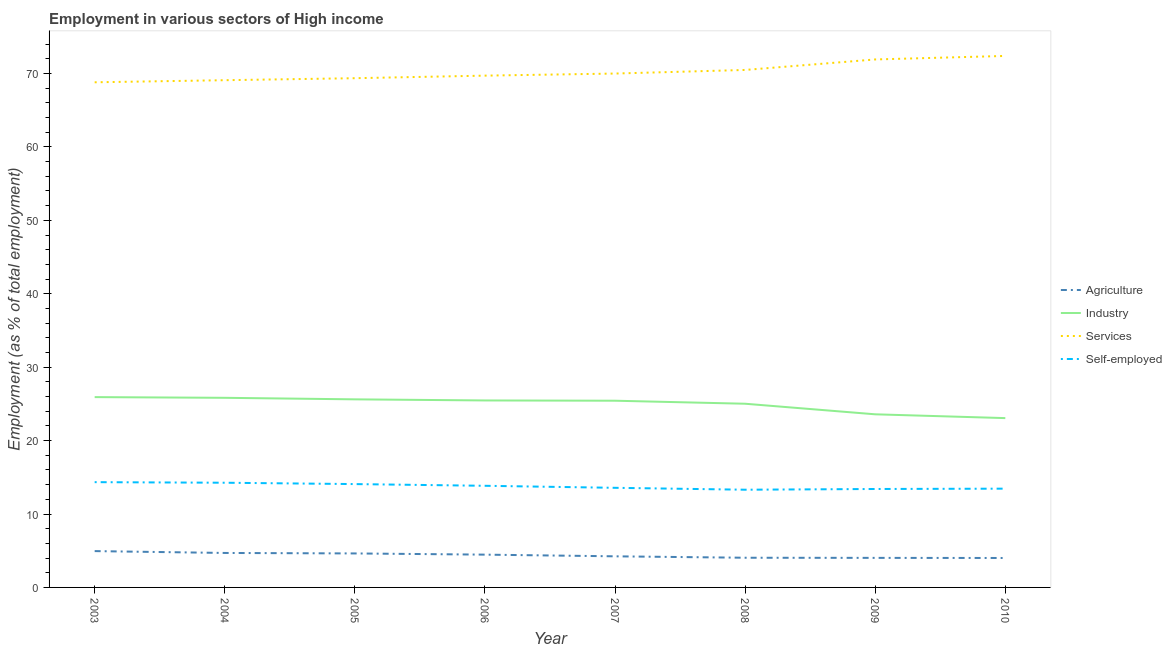How many different coloured lines are there?
Your response must be concise. 4. Does the line corresponding to percentage of self employed workers intersect with the line corresponding to percentage of workers in agriculture?
Make the answer very short. No. What is the percentage of workers in agriculture in 2008?
Ensure brevity in your answer.  4.04. Across all years, what is the maximum percentage of workers in agriculture?
Your response must be concise. 4.95. Across all years, what is the minimum percentage of workers in services?
Offer a very short reply. 68.81. In which year was the percentage of workers in industry maximum?
Your answer should be very brief. 2003. In which year was the percentage of self employed workers minimum?
Your response must be concise. 2008. What is the total percentage of workers in agriculture in the graph?
Keep it short and to the point. 35.06. What is the difference between the percentage of workers in industry in 2003 and that in 2008?
Offer a terse response. 0.9. What is the difference between the percentage of workers in agriculture in 2009 and the percentage of workers in industry in 2010?
Your answer should be compact. -19.04. What is the average percentage of self employed workers per year?
Give a very brief answer. 13.78. In the year 2003, what is the difference between the percentage of self employed workers and percentage of workers in services?
Your answer should be very brief. -54.47. What is the ratio of the percentage of self employed workers in 2003 to that in 2010?
Offer a terse response. 1.07. Is the percentage of workers in agriculture in 2003 less than that in 2009?
Offer a very short reply. No. What is the difference between the highest and the second highest percentage of self employed workers?
Offer a terse response. 0.08. What is the difference between the highest and the lowest percentage of workers in agriculture?
Your answer should be very brief. 0.94. In how many years, is the percentage of workers in industry greater than the average percentage of workers in industry taken over all years?
Provide a short and direct response. 6. Is the sum of the percentage of workers in agriculture in 2004 and 2008 greater than the maximum percentage of workers in industry across all years?
Your answer should be very brief. No. Does the percentage of workers in industry monotonically increase over the years?
Your response must be concise. No. Is the percentage of workers in services strictly greater than the percentage of workers in industry over the years?
Provide a succinct answer. Yes. What is the difference between two consecutive major ticks on the Y-axis?
Keep it short and to the point. 10. Are the values on the major ticks of Y-axis written in scientific E-notation?
Give a very brief answer. No. Does the graph contain any zero values?
Offer a very short reply. No. Does the graph contain grids?
Your answer should be very brief. No. Where does the legend appear in the graph?
Ensure brevity in your answer.  Center right. What is the title of the graph?
Provide a succinct answer. Employment in various sectors of High income. Does "Public resource use" appear as one of the legend labels in the graph?
Your answer should be compact. No. What is the label or title of the Y-axis?
Make the answer very short. Employment (as % of total employment). What is the Employment (as % of total employment) in Agriculture in 2003?
Your answer should be compact. 4.95. What is the Employment (as % of total employment) of Industry in 2003?
Provide a short and direct response. 25.92. What is the Employment (as % of total employment) of Services in 2003?
Your answer should be compact. 68.81. What is the Employment (as % of total employment) in Self-employed in 2003?
Provide a succinct answer. 14.34. What is the Employment (as % of total employment) in Agriculture in 2004?
Offer a terse response. 4.7. What is the Employment (as % of total employment) in Industry in 2004?
Give a very brief answer. 25.83. What is the Employment (as % of total employment) of Services in 2004?
Your response must be concise. 69.09. What is the Employment (as % of total employment) in Self-employed in 2004?
Offer a terse response. 14.26. What is the Employment (as % of total employment) of Agriculture in 2005?
Offer a very short reply. 4.63. What is the Employment (as % of total employment) in Industry in 2005?
Keep it short and to the point. 25.62. What is the Employment (as % of total employment) of Services in 2005?
Provide a short and direct response. 69.36. What is the Employment (as % of total employment) of Self-employed in 2005?
Give a very brief answer. 14.08. What is the Employment (as % of total employment) of Agriculture in 2006?
Give a very brief answer. 4.47. What is the Employment (as % of total employment) in Industry in 2006?
Provide a succinct answer. 25.47. What is the Employment (as % of total employment) of Services in 2006?
Ensure brevity in your answer.  69.71. What is the Employment (as % of total employment) in Self-employed in 2006?
Your response must be concise. 13.84. What is the Employment (as % of total employment) of Agriculture in 2007?
Ensure brevity in your answer.  4.24. What is the Employment (as % of total employment) of Industry in 2007?
Your answer should be very brief. 25.43. What is the Employment (as % of total employment) in Services in 2007?
Keep it short and to the point. 70. What is the Employment (as % of total employment) of Self-employed in 2007?
Make the answer very short. 13.57. What is the Employment (as % of total employment) of Agriculture in 2008?
Offer a terse response. 4.04. What is the Employment (as % of total employment) in Industry in 2008?
Ensure brevity in your answer.  25.02. What is the Employment (as % of total employment) in Services in 2008?
Your answer should be very brief. 70.49. What is the Employment (as % of total employment) of Self-employed in 2008?
Your answer should be compact. 13.31. What is the Employment (as % of total employment) of Agriculture in 2009?
Offer a very short reply. 4.03. What is the Employment (as % of total employment) of Industry in 2009?
Give a very brief answer. 23.58. What is the Employment (as % of total employment) in Services in 2009?
Your answer should be compact. 71.92. What is the Employment (as % of total employment) of Self-employed in 2009?
Ensure brevity in your answer.  13.41. What is the Employment (as % of total employment) in Agriculture in 2010?
Provide a succinct answer. 4.01. What is the Employment (as % of total employment) of Industry in 2010?
Offer a very short reply. 23.06. What is the Employment (as % of total employment) in Services in 2010?
Your answer should be very brief. 72.4. What is the Employment (as % of total employment) in Self-employed in 2010?
Ensure brevity in your answer.  13.45. Across all years, what is the maximum Employment (as % of total employment) in Agriculture?
Make the answer very short. 4.95. Across all years, what is the maximum Employment (as % of total employment) of Industry?
Your answer should be compact. 25.92. Across all years, what is the maximum Employment (as % of total employment) in Services?
Keep it short and to the point. 72.4. Across all years, what is the maximum Employment (as % of total employment) in Self-employed?
Ensure brevity in your answer.  14.34. Across all years, what is the minimum Employment (as % of total employment) in Agriculture?
Your response must be concise. 4.01. Across all years, what is the minimum Employment (as % of total employment) of Industry?
Make the answer very short. 23.06. Across all years, what is the minimum Employment (as % of total employment) in Services?
Your answer should be compact. 68.81. Across all years, what is the minimum Employment (as % of total employment) of Self-employed?
Provide a succinct answer. 13.31. What is the total Employment (as % of total employment) of Agriculture in the graph?
Keep it short and to the point. 35.06. What is the total Employment (as % of total employment) of Industry in the graph?
Your answer should be very brief. 199.94. What is the total Employment (as % of total employment) of Services in the graph?
Your response must be concise. 561.78. What is the total Employment (as % of total employment) of Self-employed in the graph?
Your answer should be very brief. 110.26. What is the difference between the Employment (as % of total employment) in Agriculture in 2003 and that in 2004?
Your answer should be compact. 0.25. What is the difference between the Employment (as % of total employment) in Industry in 2003 and that in 2004?
Offer a terse response. 0.09. What is the difference between the Employment (as % of total employment) in Services in 2003 and that in 2004?
Offer a very short reply. -0.28. What is the difference between the Employment (as % of total employment) in Self-employed in 2003 and that in 2004?
Offer a terse response. 0.08. What is the difference between the Employment (as % of total employment) in Agriculture in 2003 and that in 2005?
Your answer should be compact. 0.32. What is the difference between the Employment (as % of total employment) in Industry in 2003 and that in 2005?
Offer a very short reply. 0.3. What is the difference between the Employment (as % of total employment) in Services in 2003 and that in 2005?
Offer a terse response. -0.56. What is the difference between the Employment (as % of total employment) in Self-employed in 2003 and that in 2005?
Provide a short and direct response. 0.26. What is the difference between the Employment (as % of total employment) in Agriculture in 2003 and that in 2006?
Provide a succinct answer. 0.48. What is the difference between the Employment (as % of total employment) in Industry in 2003 and that in 2006?
Give a very brief answer. 0.45. What is the difference between the Employment (as % of total employment) in Services in 2003 and that in 2006?
Your response must be concise. -0.91. What is the difference between the Employment (as % of total employment) of Self-employed in 2003 and that in 2006?
Provide a short and direct response. 0.5. What is the difference between the Employment (as % of total employment) of Agriculture in 2003 and that in 2007?
Ensure brevity in your answer.  0.71. What is the difference between the Employment (as % of total employment) in Industry in 2003 and that in 2007?
Your response must be concise. 0.49. What is the difference between the Employment (as % of total employment) in Services in 2003 and that in 2007?
Keep it short and to the point. -1.19. What is the difference between the Employment (as % of total employment) in Self-employed in 2003 and that in 2007?
Provide a short and direct response. 0.77. What is the difference between the Employment (as % of total employment) in Agriculture in 2003 and that in 2008?
Make the answer very short. 0.9. What is the difference between the Employment (as % of total employment) of Industry in 2003 and that in 2008?
Offer a very short reply. 0.9. What is the difference between the Employment (as % of total employment) in Services in 2003 and that in 2008?
Keep it short and to the point. -1.68. What is the difference between the Employment (as % of total employment) in Self-employed in 2003 and that in 2008?
Provide a short and direct response. 1.03. What is the difference between the Employment (as % of total employment) in Agriculture in 2003 and that in 2009?
Your response must be concise. 0.92. What is the difference between the Employment (as % of total employment) in Industry in 2003 and that in 2009?
Provide a succinct answer. 2.34. What is the difference between the Employment (as % of total employment) of Services in 2003 and that in 2009?
Your response must be concise. -3.11. What is the difference between the Employment (as % of total employment) in Self-employed in 2003 and that in 2009?
Ensure brevity in your answer.  0.93. What is the difference between the Employment (as % of total employment) of Agriculture in 2003 and that in 2010?
Your answer should be compact. 0.94. What is the difference between the Employment (as % of total employment) in Industry in 2003 and that in 2010?
Offer a very short reply. 2.86. What is the difference between the Employment (as % of total employment) of Services in 2003 and that in 2010?
Provide a short and direct response. -3.59. What is the difference between the Employment (as % of total employment) in Self-employed in 2003 and that in 2010?
Offer a very short reply. 0.89. What is the difference between the Employment (as % of total employment) of Agriculture in 2004 and that in 2005?
Keep it short and to the point. 0.07. What is the difference between the Employment (as % of total employment) of Industry in 2004 and that in 2005?
Provide a succinct answer. 0.21. What is the difference between the Employment (as % of total employment) of Services in 2004 and that in 2005?
Offer a very short reply. -0.27. What is the difference between the Employment (as % of total employment) in Self-employed in 2004 and that in 2005?
Provide a succinct answer. 0.18. What is the difference between the Employment (as % of total employment) of Agriculture in 2004 and that in 2006?
Offer a very short reply. 0.23. What is the difference between the Employment (as % of total employment) in Industry in 2004 and that in 2006?
Keep it short and to the point. 0.36. What is the difference between the Employment (as % of total employment) of Services in 2004 and that in 2006?
Offer a very short reply. -0.62. What is the difference between the Employment (as % of total employment) of Self-employed in 2004 and that in 2006?
Your answer should be very brief. 0.42. What is the difference between the Employment (as % of total employment) of Agriculture in 2004 and that in 2007?
Ensure brevity in your answer.  0.46. What is the difference between the Employment (as % of total employment) of Industry in 2004 and that in 2007?
Provide a succinct answer. 0.4. What is the difference between the Employment (as % of total employment) in Services in 2004 and that in 2007?
Make the answer very short. -0.91. What is the difference between the Employment (as % of total employment) of Self-employed in 2004 and that in 2007?
Your answer should be very brief. 0.69. What is the difference between the Employment (as % of total employment) in Agriculture in 2004 and that in 2008?
Ensure brevity in your answer.  0.65. What is the difference between the Employment (as % of total employment) in Industry in 2004 and that in 2008?
Your answer should be compact. 0.81. What is the difference between the Employment (as % of total employment) of Services in 2004 and that in 2008?
Your response must be concise. -1.4. What is the difference between the Employment (as % of total employment) of Self-employed in 2004 and that in 2008?
Ensure brevity in your answer.  0.95. What is the difference between the Employment (as % of total employment) in Agriculture in 2004 and that in 2009?
Your response must be concise. 0.67. What is the difference between the Employment (as % of total employment) in Industry in 2004 and that in 2009?
Ensure brevity in your answer.  2.25. What is the difference between the Employment (as % of total employment) in Services in 2004 and that in 2009?
Keep it short and to the point. -2.83. What is the difference between the Employment (as % of total employment) in Self-employed in 2004 and that in 2009?
Offer a terse response. 0.85. What is the difference between the Employment (as % of total employment) in Agriculture in 2004 and that in 2010?
Your answer should be compact. 0.69. What is the difference between the Employment (as % of total employment) in Industry in 2004 and that in 2010?
Provide a succinct answer. 2.76. What is the difference between the Employment (as % of total employment) of Services in 2004 and that in 2010?
Your answer should be very brief. -3.31. What is the difference between the Employment (as % of total employment) of Self-employed in 2004 and that in 2010?
Your answer should be compact. 0.81. What is the difference between the Employment (as % of total employment) in Agriculture in 2005 and that in 2006?
Make the answer very short. 0.16. What is the difference between the Employment (as % of total employment) of Industry in 2005 and that in 2006?
Provide a succinct answer. 0.15. What is the difference between the Employment (as % of total employment) of Services in 2005 and that in 2006?
Your response must be concise. -0.35. What is the difference between the Employment (as % of total employment) of Self-employed in 2005 and that in 2006?
Your answer should be compact. 0.23. What is the difference between the Employment (as % of total employment) in Agriculture in 2005 and that in 2007?
Make the answer very short. 0.39. What is the difference between the Employment (as % of total employment) of Industry in 2005 and that in 2007?
Offer a terse response. 0.19. What is the difference between the Employment (as % of total employment) of Services in 2005 and that in 2007?
Your answer should be compact. -0.63. What is the difference between the Employment (as % of total employment) of Self-employed in 2005 and that in 2007?
Keep it short and to the point. 0.51. What is the difference between the Employment (as % of total employment) of Agriculture in 2005 and that in 2008?
Your response must be concise. 0.59. What is the difference between the Employment (as % of total employment) in Industry in 2005 and that in 2008?
Provide a short and direct response. 0.6. What is the difference between the Employment (as % of total employment) in Services in 2005 and that in 2008?
Keep it short and to the point. -1.12. What is the difference between the Employment (as % of total employment) in Self-employed in 2005 and that in 2008?
Make the answer very short. 0.77. What is the difference between the Employment (as % of total employment) of Agriculture in 2005 and that in 2009?
Make the answer very short. 0.6. What is the difference between the Employment (as % of total employment) in Industry in 2005 and that in 2009?
Give a very brief answer. 2.04. What is the difference between the Employment (as % of total employment) in Services in 2005 and that in 2009?
Offer a very short reply. -2.55. What is the difference between the Employment (as % of total employment) in Self-employed in 2005 and that in 2009?
Provide a succinct answer. 0.67. What is the difference between the Employment (as % of total employment) in Agriculture in 2005 and that in 2010?
Offer a terse response. 0.62. What is the difference between the Employment (as % of total employment) of Industry in 2005 and that in 2010?
Offer a terse response. 2.56. What is the difference between the Employment (as % of total employment) in Services in 2005 and that in 2010?
Make the answer very short. -3.03. What is the difference between the Employment (as % of total employment) in Self-employed in 2005 and that in 2010?
Provide a short and direct response. 0.62. What is the difference between the Employment (as % of total employment) in Agriculture in 2006 and that in 2007?
Ensure brevity in your answer.  0.23. What is the difference between the Employment (as % of total employment) of Industry in 2006 and that in 2007?
Provide a short and direct response. 0.04. What is the difference between the Employment (as % of total employment) in Services in 2006 and that in 2007?
Your answer should be compact. -0.28. What is the difference between the Employment (as % of total employment) in Self-employed in 2006 and that in 2007?
Offer a very short reply. 0.28. What is the difference between the Employment (as % of total employment) of Agriculture in 2006 and that in 2008?
Your answer should be compact. 0.42. What is the difference between the Employment (as % of total employment) of Industry in 2006 and that in 2008?
Provide a succinct answer. 0.45. What is the difference between the Employment (as % of total employment) of Services in 2006 and that in 2008?
Provide a succinct answer. -0.77. What is the difference between the Employment (as % of total employment) of Self-employed in 2006 and that in 2008?
Keep it short and to the point. 0.53. What is the difference between the Employment (as % of total employment) of Agriculture in 2006 and that in 2009?
Keep it short and to the point. 0.44. What is the difference between the Employment (as % of total employment) of Industry in 2006 and that in 2009?
Provide a succinct answer. 1.89. What is the difference between the Employment (as % of total employment) of Services in 2006 and that in 2009?
Give a very brief answer. -2.21. What is the difference between the Employment (as % of total employment) in Self-employed in 2006 and that in 2009?
Offer a very short reply. 0.44. What is the difference between the Employment (as % of total employment) of Agriculture in 2006 and that in 2010?
Provide a short and direct response. 0.46. What is the difference between the Employment (as % of total employment) in Industry in 2006 and that in 2010?
Your response must be concise. 2.4. What is the difference between the Employment (as % of total employment) of Services in 2006 and that in 2010?
Keep it short and to the point. -2.68. What is the difference between the Employment (as % of total employment) in Self-employed in 2006 and that in 2010?
Make the answer very short. 0.39. What is the difference between the Employment (as % of total employment) in Agriculture in 2007 and that in 2008?
Offer a very short reply. 0.19. What is the difference between the Employment (as % of total employment) of Industry in 2007 and that in 2008?
Provide a succinct answer. 0.41. What is the difference between the Employment (as % of total employment) in Services in 2007 and that in 2008?
Make the answer very short. -0.49. What is the difference between the Employment (as % of total employment) of Self-employed in 2007 and that in 2008?
Offer a terse response. 0.26. What is the difference between the Employment (as % of total employment) of Agriculture in 2007 and that in 2009?
Make the answer very short. 0.21. What is the difference between the Employment (as % of total employment) of Industry in 2007 and that in 2009?
Your response must be concise. 1.85. What is the difference between the Employment (as % of total employment) of Services in 2007 and that in 2009?
Offer a very short reply. -1.92. What is the difference between the Employment (as % of total employment) in Self-employed in 2007 and that in 2009?
Your response must be concise. 0.16. What is the difference between the Employment (as % of total employment) in Agriculture in 2007 and that in 2010?
Your response must be concise. 0.23. What is the difference between the Employment (as % of total employment) in Industry in 2007 and that in 2010?
Ensure brevity in your answer.  2.37. What is the difference between the Employment (as % of total employment) in Services in 2007 and that in 2010?
Offer a very short reply. -2.4. What is the difference between the Employment (as % of total employment) of Self-employed in 2007 and that in 2010?
Make the answer very short. 0.11. What is the difference between the Employment (as % of total employment) of Agriculture in 2008 and that in 2009?
Your answer should be compact. 0.02. What is the difference between the Employment (as % of total employment) in Industry in 2008 and that in 2009?
Your answer should be compact. 1.44. What is the difference between the Employment (as % of total employment) of Services in 2008 and that in 2009?
Give a very brief answer. -1.43. What is the difference between the Employment (as % of total employment) in Self-employed in 2008 and that in 2009?
Make the answer very short. -0.1. What is the difference between the Employment (as % of total employment) of Agriculture in 2008 and that in 2010?
Your answer should be compact. 0.03. What is the difference between the Employment (as % of total employment) of Industry in 2008 and that in 2010?
Your response must be concise. 1.96. What is the difference between the Employment (as % of total employment) of Services in 2008 and that in 2010?
Offer a very short reply. -1.91. What is the difference between the Employment (as % of total employment) of Self-employed in 2008 and that in 2010?
Your response must be concise. -0.14. What is the difference between the Employment (as % of total employment) in Agriculture in 2009 and that in 2010?
Make the answer very short. 0.02. What is the difference between the Employment (as % of total employment) of Industry in 2009 and that in 2010?
Offer a very short reply. 0.52. What is the difference between the Employment (as % of total employment) in Services in 2009 and that in 2010?
Provide a short and direct response. -0.48. What is the difference between the Employment (as % of total employment) of Self-employed in 2009 and that in 2010?
Give a very brief answer. -0.05. What is the difference between the Employment (as % of total employment) in Agriculture in 2003 and the Employment (as % of total employment) in Industry in 2004?
Provide a succinct answer. -20.88. What is the difference between the Employment (as % of total employment) of Agriculture in 2003 and the Employment (as % of total employment) of Services in 2004?
Provide a succinct answer. -64.14. What is the difference between the Employment (as % of total employment) in Agriculture in 2003 and the Employment (as % of total employment) in Self-employed in 2004?
Ensure brevity in your answer.  -9.31. What is the difference between the Employment (as % of total employment) of Industry in 2003 and the Employment (as % of total employment) of Services in 2004?
Your answer should be compact. -43.17. What is the difference between the Employment (as % of total employment) of Industry in 2003 and the Employment (as % of total employment) of Self-employed in 2004?
Your answer should be compact. 11.66. What is the difference between the Employment (as % of total employment) of Services in 2003 and the Employment (as % of total employment) of Self-employed in 2004?
Offer a very short reply. 54.55. What is the difference between the Employment (as % of total employment) of Agriculture in 2003 and the Employment (as % of total employment) of Industry in 2005?
Offer a very short reply. -20.67. What is the difference between the Employment (as % of total employment) in Agriculture in 2003 and the Employment (as % of total employment) in Services in 2005?
Your answer should be very brief. -64.42. What is the difference between the Employment (as % of total employment) in Agriculture in 2003 and the Employment (as % of total employment) in Self-employed in 2005?
Your answer should be very brief. -9.13. What is the difference between the Employment (as % of total employment) of Industry in 2003 and the Employment (as % of total employment) of Services in 2005?
Give a very brief answer. -43.44. What is the difference between the Employment (as % of total employment) of Industry in 2003 and the Employment (as % of total employment) of Self-employed in 2005?
Provide a short and direct response. 11.85. What is the difference between the Employment (as % of total employment) in Services in 2003 and the Employment (as % of total employment) in Self-employed in 2005?
Your answer should be compact. 54.73. What is the difference between the Employment (as % of total employment) of Agriculture in 2003 and the Employment (as % of total employment) of Industry in 2006?
Ensure brevity in your answer.  -20.52. What is the difference between the Employment (as % of total employment) in Agriculture in 2003 and the Employment (as % of total employment) in Services in 2006?
Ensure brevity in your answer.  -64.77. What is the difference between the Employment (as % of total employment) in Agriculture in 2003 and the Employment (as % of total employment) in Self-employed in 2006?
Ensure brevity in your answer.  -8.9. What is the difference between the Employment (as % of total employment) of Industry in 2003 and the Employment (as % of total employment) of Services in 2006?
Your answer should be very brief. -43.79. What is the difference between the Employment (as % of total employment) of Industry in 2003 and the Employment (as % of total employment) of Self-employed in 2006?
Your response must be concise. 12.08. What is the difference between the Employment (as % of total employment) in Services in 2003 and the Employment (as % of total employment) in Self-employed in 2006?
Ensure brevity in your answer.  54.96. What is the difference between the Employment (as % of total employment) in Agriculture in 2003 and the Employment (as % of total employment) in Industry in 2007?
Make the answer very short. -20.48. What is the difference between the Employment (as % of total employment) of Agriculture in 2003 and the Employment (as % of total employment) of Services in 2007?
Your response must be concise. -65.05. What is the difference between the Employment (as % of total employment) in Agriculture in 2003 and the Employment (as % of total employment) in Self-employed in 2007?
Keep it short and to the point. -8.62. What is the difference between the Employment (as % of total employment) of Industry in 2003 and the Employment (as % of total employment) of Services in 2007?
Provide a succinct answer. -44.08. What is the difference between the Employment (as % of total employment) in Industry in 2003 and the Employment (as % of total employment) in Self-employed in 2007?
Make the answer very short. 12.35. What is the difference between the Employment (as % of total employment) in Services in 2003 and the Employment (as % of total employment) in Self-employed in 2007?
Your answer should be compact. 55.24. What is the difference between the Employment (as % of total employment) of Agriculture in 2003 and the Employment (as % of total employment) of Industry in 2008?
Your answer should be compact. -20.07. What is the difference between the Employment (as % of total employment) of Agriculture in 2003 and the Employment (as % of total employment) of Services in 2008?
Keep it short and to the point. -65.54. What is the difference between the Employment (as % of total employment) in Agriculture in 2003 and the Employment (as % of total employment) in Self-employed in 2008?
Give a very brief answer. -8.36. What is the difference between the Employment (as % of total employment) of Industry in 2003 and the Employment (as % of total employment) of Services in 2008?
Provide a short and direct response. -44.56. What is the difference between the Employment (as % of total employment) of Industry in 2003 and the Employment (as % of total employment) of Self-employed in 2008?
Keep it short and to the point. 12.61. What is the difference between the Employment (as % of total employment) of Services in 2003 and the Employment (as % of total employment) of Self-employed in 2008?
Offer a very short reply. 55.5. What is the difference between the Employment (as % of total employment) of Agriculture in 2003 and the Employment (as % of total employment) of Industry in 2009?
Ensure brevity in your answer.  -18.63. What is the difference between the Employment (as % of total employment) of Agriculture in 2003 and the Employment (as % of total employment) of Services in 2009?
Provide a short and direct response. -66.97. What is the difference between the Employment (as % of total employment) in Agriculture in 2003 and the Employment (as % of total employment) in Self-employed in 2009?
Provide a succinct answer. -8.46. What is the difference between the Employment (as % of total employment) in Industry in 2003 and the Employment (as % of total employment) in Services in 2009?
Offer a terse response. -46. What is the difference between the Employment (as % of total employment) of Industry in 2003 and the Employment (as % of total employment) of Self-employed in 2009?
Your response must be concise. 12.51. What is the difference between the Employment (as % of total employment) of Services in 2003 and the Employment (as % of total employment) of Self-employed in 2009?
Ensure brevity in your answer.  55.4. What is the difference between the Employment (as % of total employment) of Agriculture in 2003 and the Employment (as % of total employment) of Industry in 2010?
Offer a very short reply. -18.12. What is the difference between the Employment (as % of total employment) of Agriculture in 2003 and the Employment (as % of total employment) of Services in 2010?
Make the answer very short. -67.45. What is the difference between the Employment (as % of total employment) of Agriculture in 2003 and the Employment (as % of total employment) of Self-employed in 2010?
Make the answer very short. -8.51. What is the difference between the Employment (as % of total employment) in Industry in 2003 and the Employment (as % of total employment) in Services in 2010?
Your answer should be very brief. -46.47. What is the difference between the Employment (as % of total employment) in Industry in 2003 and the Employment (as % of total employment) in Self-employed in 2010?
Offer a very short reply. 12.47. What is the difference between the Employment (as % of total employment) in Services in 2003 and the Employment (as % of total employment) in Self-employed in 2010?
Ensure brevity in your answer.  55.35. What is the difference between the Employment (as % of total employment) of Agriculture in 2004 and the Employment (as % of total employment) of Industry in 2005?
Ensure brevity in your answer.  -20.92. What is the difference between the Employment (as % of total employment) in Agriculture in 2004 and the Employment (as % of total employment) in Services in 2005?
Make the answer very short. -64.67. What is the difference between the Employment (as % of total employment) in Agriculture in 2004 and the Employment (as % of total employment) in Self-employed in 2005?
Offer a very short reply. -9.38. What is the difference between the Employment (as % of total employment) in Industry in 2004 and the Employment (as % of total employment) in Services in 2005?
Provide a short and direct response. -43.54. What is the difference between the Employment (as % of total employment) in Industry in 2004 and the Employment (as % of total employment) in Self-employed in 2005?
Keep it short and to the point. 11.75. What is the difference between the Employment (as % of total employment) in Services in 2004 and the Employment (as % of total employment) in Self-employed in 2005?
Provide a short and direct response. 55.02. What is the difference between the Employment (as % of total employment) in Agriculture in 2004 and the Employment (as % of total employment) in Industry in 2006?
Your answer should be compact. -20.77. What is the difference between the Employment (as % of total employment) of Agriculture in 2004 and the Employment (as % of total employment) of Services in 2006?
Ensure brevity in your answer.  -65.02. What is the difference between the Employment (as % of total employment) of Agriculture in 2004 and the Employment (as % of total employment) of Self-employed in 2006?
Provide a succinct answer. -9.15. What is the difference between the Employment (as % of total employment) in Industry in 2004 and the Employment (as % of total employment) in Services in 2006?
Offer a terse response. -43.89. What is the difference between the Employment (as % of total employment) in Industry in 2004 and the Employment (as % of total employment) in Self-employed in 2006?
Offer a terse response. 11.98. What is the difference between the Employment (as % of total employment) of Services in 2004 and the Employment (as % of total employment) of Self-employed in 2006?
Your response must be concise. 55.25. What is the difference between the Employment (as % of total employment) in Agriculture in 2004 and the Employment (as % of total employment) in Industry in 2007?
Offer a terse response. -20.74. What is the difference between the Employment (as % of total employment) of Agriculture in 2004 and the Employment (as % of total employment) of Services in 2007?
Ensure brevity in your answer.  -65.3. What is the difference between the Employment (as % of total employment) in Agriculture in 2004 and the Employment (as % of total employment) in Self-employed in 2007?
Ensure brevity in your answer.  -8.87. What is the difference between the Employment (as % of total employment) of Industry in 2004 and the Employment (as % of total employment) of Services in 2007?
Make the answer very short. -44.17. What is the difference between the Employment (as % of total employment) in Industry in 2004 and the Employment (as % of total employment) in Self-employed in 2007?
Keep it short and to the point. 12.26. What is the difference between the Employment (as % of total employment) in Services in 2004 and the Employment (as % of total employment) in Self-employed in 2007?
Make the answer very short. 55.52. What is the difference between the Employment (as % of total employment) in Agriculture in 2004 and the Employment (as % of total employment) in Industry in 2008?
Your response must be concise. -20.33. What is the difference between the Employment (as % of total employment) in Agriculture in 2004 and the Employment (as % of total employment) in Services in 2008?
Give a very brief answer. -65.79. What is the difference between the Employment (as % of total employment) of Agriculture in 2004 and the Employment (as % of total employment) of Self-employed in 2008?
Give a very brief answer. -8.61. What is the difference between the Employment (as % of total employment) of Industry in 2004 and the Employment (as % of total employment) of Services in 2008?
Your answer should be compact. -44.66. What is the difference between the Employment (as % of total employment) of Industry in 2004 and the Employment (as % of total employment) of Self-employed in 2008?
Offer a terse response. 12.52. What is the difference between the Employment (as % of total employment) in Services in 2004 and the Employment (as % of total employment) in Self-employed in 2008?
Your response must be concise. 55.78. What is the difference between the Employment (as % of total employment) in Agriculture in 2004 and the Employment (as % of total employment) in Industry in 2009?
Your answer should be very brief. -18.88. What is the difference between the Employment (as % of total employment) of Agriculture in 2004 and the Employment (as % of total employment) of Services in 2009?
Give a very brief answer. -67.22. What is the difference between the Employment (as % of total employment) of Agriculture in 2004 and the Employment (as % of total employment) of Self-employed in 2009?
Provide a succinct answer. -8.71. What is the difference between the Employment (as % of total employment) in Industry in 2004 and the Employment (as % of total employment) in Services in 2009?
Offer a terse response. -46.09. What is the difference between the Employment (as % of total employment) in Industry in 2004 and the Employment (as % of total employment) in Self-employed in 2009?
Offer a very short reply. 12.42. What is the difference between the Employment (as % of total employment) of Services in 2004 and the Employment (as % of total employment) of Self-employed in 2009?
Ensure brevity in your answer.  55.68. What is the difference between the Employment (as % of total employment) of Agriculture in 2004 and the Employment (as % of total employment) of Industry in 2010?
Keep it short and to the point. -18.37. What is the difference between the Employment (as % of total employment) in Agriculture in 2004 and the Employment (as % of total employment) in Services in 2010?
Provide a succinct answer. -67.7. What is the difference between the Employment (as % of total employment) of Agriculture in 2004 and the Employment (as % of total employment) of Self-employed in 2010?
Offer a terse response. -8.76. What is the difference between the Employment (as % of total employment) in Industry in 2004 and the Employment (as % of total employment) in Services in 2010?
Provide a succinct answer. -46.57. What is the difference between the Employment (as % of total employment) in Industry in 2004 and the Employment (as % of total employment) in Self-employed in 2010?
Your answer should be very brief. 12.37. What is the difference between the Employment (as % of total employment) of Services in 2004 and the Employment (as % of total employment) of Self-employed in 2010?
Keep it short and to the point. 55.64. What is the difference between the Employment (as % of total employment) of Agriculture in 2005 and the Employment (as % of total employment) of Industry in 2006?
Provide a short and direct response. -20.84. What is the difference between the Employment (as % of total employment) of Agriculture in 2005 and the Employment (as % of total employment) of Services in 2006?
Offer a very short reply. -65.08. What is the difference between the Employment (as % of total employment) in Agriculture in 2005 and the Employment (as % of total employment) in Self-employed in 2006?
Your response must be concise. -9.21. What is the difference between the Employment (as % of total employment) of Industry in 2005 and the Employment (as % of total employment) of Services in 2006?
Offer a very short reply. -44.09. What is the difference between the Employment (as % of total employment) of Industry in 2005 and the Employment (as % of total employment) of Self-employed in 2006?
Offer a terse response. 11.78. What is the difference between the Employment (as % of total employment) in Services in 2005 and the Employment (as % of total employment) in Self-employed in 2006?
Your response must be concise. 55.52. What is the difference between the Employment (as % of total employment) of Agriculture in 2005 and the Employment (as % of total employment) of Industry in 2007?
Provide a short and direct response. -20.8. What is the difference between the Employment (as % of total employment) of Agriculture in 2005 and the Employment (as % of total employment) of Services in 2007?
Make the answer very short. -65.37. What is the difference between the Employment (as % of total employment) of Agriculture in 2005 and the Employment (as % of total employment) of Self-employed in 2007?
Make the answer very short. -8.94. What is the difference between the Employment (as % of total employment) of Industry in 2005 and the Employment (as % of total employment) of Services in 2007?
Your answer should be very brief. -44.38. What is the difference between the Employment (as % of total employment) of Industry in 2005 and the Employment (as % of total employment) of Self-employed in 2007?
Provide a short and direct response. 12.05. What is the difference between the Employment (as % of total employment) of Services in 2005 and the Employment (as % of total employment) of Self-employed in 2007?
Your answer should be very brief. 55.8. What is the difference between the Employment (as % of total employment) in Agriculture in 2005 and the Employment (as % of total employment) in Industry in 2008?
Your answer should be compact. -20.39. What is the difference between the Employment (as % of total employment) in Agriculture in 2005 and the Employment (as % of total employment) in Services in 2008?
Your answer should be very brief. -65.86. What is the difference between the Employment (as % of total employment) of Agriculture in 2005 and the Employment (as % of total employment) of Self-employed in 2008?
Give a very brief answer. -8.68. What is the difference between the Employment (as % of total employment) in Industry in 2005 and the Employment (as % of total employment) in Services in 2008?
Offer a very short reply. -44.87. What is the difference between the Employment (as % of total employment) of Industry in 2005 and the Employment (as % of total employment) of Self-employed in 2008?
Your answer should be compact. 12.31. What is the difference between the Employment (as % of total employment) of Services in 2005 and the Employment (as % of total employment) of Self-employed in 2008?
Provide a short and direct response. 56.05. What is the difference between the Employment (as % of total employment) in Agriculture in 2005 and the Employment (as % of total employment) in Industry in 2009?
Provide a short and direct response. -18.95. What is the difference between the Employment (as % of total employment) in Agriculture in 2005 and the Employment (as % of total employment) in Services in 2009?
Ensure brevity in your answer.  -67.29. What is the difference between the Employment (as % of total employment) in Agriculture in 2005 and the Employment (as % of total employment) in Self-employed in 2009?
Ensure brevity in your answer.  -8.78. What is the difference between the Employment (as % of total employment) in Industry in 2005 and the Employment (as % of total employment) in Services in 2009?
Offer a terse response. -46.3. What is the difference between the Employment (as % of total employment) in Industry in 2005 and the Employment (as % of total employment) in Self-employed in 2009?
Your response must be concise. 12.21. What is the difference between the Employment (as % of total employment) in Services in 2005 and the Employment (as % of total employment) in Self-employed in 2009?
Give a very brief answer. 55.96. What is the difference between the Employment (as % of total employment) of Agriculture in 2005 and the Employment (as % of total employment) of Industry in 2010?
Your answer should be compact. -18.43. What is the difference between the Employment (as % of total employment) of Agriculture in 2005 and the Employment (as % of total employment) of Services in 2010?
Your response must be concise. -67.77. What is the difference between the Employment (as % of total employment) in Agriculture in 2005 and the Employment (as % of total employment) in Self-employed in 2010?
Give a very brief answer. -8.82. What is the difference between the Employment (as % of total employment) in Industry in 2005 and the Employment (as % of total employment) in Services in 2010?
Offer a terse response. -46.78. What is the difference between the Employment (as % of total employment) in Industry in 2005 and the Employment (as % of total employment) in Self-employed in 2010?
Provide a succinct answer. 12.17. What is the difference between the Employment (as % of total employment) in Services in 2005 and the Employment (as % of total employment) in Self-employed in 2010?
Offer a very short reply. 55.91. What is the difference between the Employment (as % of total employment) in Agriculture in 2006 and the Employment (as % of total employment) in Industry in 2007?
Your response must be concise. -20.97. What is the difference between the Employment (as % of total employment) of Agriculture in 2006 and the Employment (as % of total employment) of Services in 2007?
Make the answer very short. -65.53. What is the difference between the Employment (as % of total employment) in Agriculture in 2006 and the Employment (as % of total employment) in Self-employed in 2007?
Offer a very short reply. -9.1. What is the difference between the Employment (as % of total employment) in Industry in 2006 and the Employment (as % of total employment) in Services in 2007?
Offer a very short reply. -44.53. What is the difference between the Employment (as % of total employment) of Industry in 2006 and the Employment (as % of total employment) of Self-employed in 2007?
Offer a very short reply. 11.9. What is the difference between the Employment (as % of total employment) of Services in 2006 and the Employment (as % of total employment) of Self-employed in 2007?
Your response must be concise. 56.15. What is the difference between the Employment (as % of total employment) of Agriculture in 2006 and the Employment (as % of total employment) of Industry in 2008?
Your response must be concise. -20.56. What is the difference between the Employment (as % of total employment) in Agriculture in 2006 and the Employment (as % of total employment) in Services in 2008?
Make the answer very short. -66.02. What is the difference between the Employment (as % of total employment) of Agriculture in 2006 and the Employment (as % of total employment) of Self-employed in 2008?
Provide a short and direct response. -8.84. What is the difference between the Employment (as % of total employment) of Industry in 2006 and the Employment (as % of total employment) of Services in 2008?
Your answer should be very brief. -45.02. What is the difference between the Employment (as % of total employment) of Industry in 2006 and the Employment (as % of total employment) of Self-employed in 2008?
Your answer should be compact. 12.16. What is the difference between the Employment (as % of total employment) in Services in 2006 and the Employment (as % of total employment) in Self-employed in 2008?
Offer a very short reply. 56.4. What is the difference between the Employment (as % of total employment) in Agriculture in 2006 and the Employment (as % of total employment) in Industry in 2009?
Your response must be concise. -19.11. What is the difference between the Employment (as % of total employment) in Agriculture in 2006 and the Employment (as % of total employment) in Services in 2009?
Offer a terse response. -67.45. What is the difference between the Employment (as % of total employment) in Agriculture in 2006 and the Employment (as % of total employment) in Self-employed in 2009?
Provide a short and direct response. -8.94. What is the difference between the Employment (as % of total employment) of Industry in 2006 and the Employment (as % of total employment) of Services in 2009?
Your answer should be very brief. -46.45. What is the difference between the Employment (as % of total employment) of Industry in 2006 and the Employment (as % of total employment) of Self-employed in 2009?
Your response must be concise. 12.06. What is the difference between the Employment (as % of total employment) in Services in 2006 and the Employment (as % of total employment) in Self-employed in 2009?
Your answer should be very brief. 56.31. What is the difference between the Employment (as % of total employment) of Agriculture in 2006 and the Employment (as % of total employment) of Industry in 2010?
Provide a succinct answer. -18.6. What is the difference between the Employment (as % of total employment) of Agriculture in 2006 and the Employment (as % of total employment) of Services in 2010?
Ensure brevity in your answer.  -67.93. What is the difference between the Employment (as % of total employment) of Agriculture in 2006 and the Employment (as % of total employment) of Self-employed in 2010?
Make the answer very short. -8.99. What is the difference between the Employment (as % of total employment) of Industry in 2006 and the Employment (as % of total employment) of Services in 2010?
Offer a very short reply. -46.93. What is the difference between the Employment (as % of total employment) of Industry in 2006 and the Employment (as % of total employment) of Self-employed in 2010?
Make the answer very short. 12.01. What is the difference between the Employment (as % of total employment) in Services in 2006 and the Employment (as % of total employment) in Self-employed in 2010?
Offer a very short reply. 56.26. What is the difference between the Employment (as % of total employment) of Agriculture in 2007 and the Employment (as % of total employment) of Industry in 2008?
Give a very brief answer. -20.78. What is the difference between the Employment (as % of total employment) in Agriculture in 2007 and the Employment (as % of total employment) in Services in 2008?
Your answer should be compact. -66.25. What is the difference between the Employment (as % of total employment) of Agriculture in 2007 and the Employment (as % of total employment) of Self-employed in 2008?
Give a very brief answer. -9.07. What is the difference between the Employment (as % of total employment) in Industry in 2007 and the Employment (as % of total employment) in Services in 2008?
Keep it short and to the point. -45.06. What is the difference between the Employment (as % of total employment) of Industry in 2007 and the Employment (as % of total employment) of Self-employed in 2008?
Give a very brief answer. 12.12. What is the difference between the Employment (as % of total employment) of Services in 2007 and the Employment (as % of total employment) of Self-employed in 2008?
Ensure brevity in your answer.  56.69. What is the difference between the Employment (as % of total employment) of Agriculture in 2007 and the Employment (as % of total employment) of Industry in 2009?
Ensure brevity in your answer.  -19.34. What is the difference between the Employment (as % of total employment) of Agriculture in 2007 and the Employment (as % of total employment) of Services in 2009?
Make the answer very short. -67.68. What is the difference between the Employment (as % of total employment) of Agriculture in 2007 and the Employment (as % of total employment) of Self-employed in 2009?
Offer a very short reply. -9.17. What is the difference between the Employment (as % of total employment) in Industry in 2007 and the Employment (as % of total employment) in Services in 2009?
Provide a short and direct response. -46.49. What is the difference between the Employment (as % of total employment) in Industry in 2007 and the Employment (as % of total employment) in Self-employed in 2009?
Your response must be concise. 12.02. What is the difference between the Employment (as % of total employment) in Services in 2007 and the Employment (as % of total employment) in Self-employed in 2009?
Ensure brevity in your answer.  56.59. What is the difference between the Employment (as % of total employment) in Agriculture in 2007 and the Employment (as % of total employment) in Industry in 2010?
Keep it short and to the point. -18.83. What is the difference between the Employment (as % of total employment) of Agriculture in 2007 and the Employment (as % of total employment) of Services in 2010?
Give a very brief answer. -68.16. What is the difference between the Employment (as % of total employment) in Agriculture in 2007 and the Employment (as % of total employment) in Self-employed in 2010?
Offer a very short reply. -9.22. What is the difference between the Employment (as % of total employment) of Industry in 2007 and the Employment (as % of total employment) of Services in 2010?
Offer a very short reply. -46.97. What is the difference between the Employment (as % of total employment) in Industry in 2007 and the Employment (as % of total employment) in Self-employed in 2010?
Provide a succinct answer. 11.98. What is the difference between the Employment (as % of total employment) in Services in 2007 and the Employment (as % of total employment) in Self-employed in 2010?
Provide a succinct answer. 56.54. What is the difference between the Employment (as % of total employment) of Agriculture in 2008 and the Employment (as % of total employment) of Industry in 2009?
Give a very brief answer. -19.54. What is the difference between the Employment (as % of total employment) in Agriculture in 2008 and the Employment (as % of total employment) in Services in 2009?
Your answer should be compact. -67.88. What is the difference between the Employment (as % of total employment) in Agriculture in 2008 and the Employment (as % of total employment) in Self-employed in 2009?
Your answer should be very brief. -9.36. What is the difference between the Employment (as % of total employment) of Industry in 2008 and the Employment (as % of total employment) of Services in 2009?
Give a very brief answer. -46.9. What is the difference between the Employment (as % of total employment) of Industry in 2008 and the Employment (as % of total employment) of Self-employed in 2009?
Give a very brief answer. 11.61. What is the difference between the Employment (as % of total employment) in Services in 2008 and the Employment (as % of total employment) in Self-employed in 2009?
Keep it short and to the point. 57.08. What is the difference between the Employment (as % of total employment) of Agriculture in 2008 and the Employment (as % of total employment) of Industry in 2010?
Offer a terse response. -19.02. What is the difference between the Employment (as % of total employment) in Agriculture in 2008 and the Employment (as % of total employment) in Services in 2010?
Offer a terse response. -68.35. What is the difference between the Employment (as % of total employment) in Agriculture in 2008 and the Employment (as % of total employment) in Self-employed in 2010?
Make the answer very short. -9.41. What is the difference between the Employment (as % of total employment) of Industry in 2008 and the Employment (as % of total employment) of Services in 2010?
Provide a short and direct response. -47.38. What is the difference between the Employment (as % of total employment) in Industry in 2008 and the Employment (as % of total employment) in Self-employed in 2010?
Offer a very short reply. 11.57. What is the difference between the Employment (as % of total employment) in Services in 2008 and the Employment (as % of total employment) in Self-employed in 2010?
Give a very brief answer. 57.03. What is the difference between the Employment (as % of total employment) in Agriculture in 2009 and the Employment (as % of total employment) in Industry in 2010?
Keep it short and to the point. -19.04. What is the difference between the Employment (as % of total employment) in Agriculture in 2009 and the Employment (as % of total employment) in Services in 2010?
Your answer should be compact. -68.37. What is the difference between the Employment (as % of total employment) in Agriculture in 2009 and the Employment (as % of total employment) in Self-employed in 2010?
Your answer should be compact. -9.43. What is the difference between the Employment (as % of total employment) of Industry in 2009 and the Employment (as % of total employment) of Services in 2010?
Keep it short and to the point. -48.82. What is the difference between the Employment (as % of total employment) in Industry in 2009 and the Employment (as % of total employment) in Self-employed in 2010?
Your response must be concise. 10.13. What is the difference between the Employment (as % of total employment) in Services in 2009 and the Employment (as % of total employment) in Self-employed in 2010?
Give a very brief answer. 58.46. What is the average Employment (as % of total employment) in Agriculture per year?
Your response must be concise. 4.38. What is the average Employment (as % of total employment) of Industry per year?
Your answer should be compact. 24.99. What is the average Employment (as % of total employment) in Services per year?
Make the answer very short. 70.22. What is the average Employment (as % of total employment) in Self-employed per year?
Offer a terse response. 13.78. In the year 2003, what is the difference between the Employment (as % of total employment) of Agriculture and Employment (as % of total employment) of Industry?
Ensure brevity in your answer.  -20.98. In the year 2003, what is the difference between the Employment (as % of total employment) in Agriculture and Employment (as % of total employment) in Services?
Ensure brevity in your answer.  -63.86. In the year 2003, what is the difference between the Employment (as % of total employment) in Agriculture and Employment (as % of total employment) in Self-employed?
Keep it short and to the point. -9.39. In the year 2003, what is the difference between the Employment (as % of total employment) of Industry and Employment (as % of total employment) of Services?
Provide a short and direct response. -42.88. In the year 2003, what is the difference between the Employment (as % of total employment) of Industry and Employment (as % of total employment) of Self-employed?
Offer a terse response. 11.58. In the year 2003, what is the difference between the Employment (as % of total employment) of Services and Employment (as % of total employment) of Self-employed?
Make the answer very short. 54.47. In the year 2004, what is the difference between the Employment (as % of total employment) of Agriculture and Employment (as % of total employment) of Industry?
Ensure brevity in your answer.  -21.13. In the year 2004, what is the difference between the Employment (as % of total employment) in Agriculture and Employment (as % of total employment) in Services?
Your answer should be very brief. -64.4. In the year 2004, what is the difference between the Employment (as % of total employment) in Agriculture and Employment (as % of total employment) in Self-employed?
Offer a terse response. -9.57. In the year 2004, what is the difference between the Employment (as % of total employment) in Industry and Employment (as % of total employment) in Services?
Offer a very short reply. -43.26. In the year 2004, what is the difference between the Employment (as % of total employment) in Industry and Employment (as % of total employment) in Self-employed?
Ensure brevity in your answer.  11.57. In the year 2004, what is the difference between the Employment (as % of total employment) of Services and Employment (as % of total employment) of Self-employed?
Make the answer very short. 54.83. In the year 2005, what is the difference between the Employment (as % of total employment) in Agriculture and Employment (as % of total employment) in Industry?
Make the answer very short. -20.99. In the year 2005, what is the difference between the Employment (as % of total employment) of Agriculture and Employment (as % of total employment) of Services?
Offer a terse response. -64.73. In the year 2005, what is the difference between the Employment (as % of total employment) of Agriculture and Employment (as % of total employment) of Self-employed?
Provide a succinct answer. -9.45. In the year 2005, what is the difference between the Employment (as % of total employment) in Industry and Employment (as % of total employment) in Services?
Give a very brief answer. -43.74. In the year 2005, what is the difference between the Employment (as % of total employment) of Industry and Employment (as % of total employment) of Self-employed?
Your answer should be compact. 11.54. In the year 2005, what is the difference between the Employment (as % of total employment) of Services and Employment (as % of total employment) of Self-employed?
Your response must be concise. 55.29. In the year 2006, what is the difference between the Employment (as % of total employment) in Agriculture and Employment (as % of total employment) in Industry?
Provide a short and direct response. -21. In the year 2006, what is the difference between the Employment (as % of total employment) in Agriculture and Employment (as % of total employment) in Services?
Keep it short and to the point. -65.25. In the year 2006, what is the difference between the Employment (as % of total employment) of Agriculture and Employment (as % of total employment) of Self-employed?
Keep it short and to the point. -9.38. In the year 2006, what is the difference between the Employment (as % of total employment) of Industry and Employment (as % of total employment) of Services?
Offer a terse response. -44.24. In the year 2006, what is the difference between the Employment (as % of total employment) of Industry and Employment (as % of total employment) of Self-employed?
Offer a very short reply. 11.62. In the year 2006, what is the difference between the Employment (as % of total employment) of Services and Employment (as % of total employment) of Self-employed?
Offer a very short reply. 55.87. In the year 2007, what is the difference between the Employment (as % of total employment) in Agriculture and Employment (as % of total employment) in Industry?
Offer a very short reply. -21.19. In the year 2007, what is the difference between the Employment (as % of total employment) of Agriculture and Employment (as % of total employment) of Services?
Provide a succinct answer. -65.76. In the year 2007, what is the difference between the Employment (as % of total employment) in Agriculture and Employment (as % of total employment) in Self-employed?
Keep it short and to the point. -9.33. In the year 2007, what is the difference between the Employment (as % of total employment) in Industry and Employment (as % of total employment) in Services?
Offer a terse response. -44.57. In the year 2007, what is the difference between the Employment (as % of total employment) of Industry and Employment (as % of total employment) of Self-employed?
Make the answer very short. 11.86. In the year 2007, what is the difference between the Employment (as % of total employment) of Services and Employment (as % of total employment) of Self-employed?
Your answer should be compact. 56.43. In the year 2008, what is the difference between the Employment (as % of total employment) of Agriculture and Employment (as % of total employment) of Industry?
Keep it short and to the point. -20.98. In the year 2008, what is the difference between the Employment (as % of total employment) in Agriculture and Employment (as % of total employment) in Services?
Offer a very short reply. -66.44. In the year 2008, what is the difference between the Employment (as % of total employment) in Agriculture and Employment (as % of total employment) in Self-employed?
Your response must be concise. -9.27. In the year 2008, what is the difference between the Employment (as % of total employment) of Industry and Employment (as % of total employment) of Services?
Provide a succinct answer. -45.47. In the year 2008, what is the difference between the Employment (as % of total employment) of Industry and Employment (as % of total employment) of Self-employed?
Make the answer very short. 11.71. In the year 2008, what is the difference between the Employment (as % of total employment) in Services and Employment (as % of total employment) in Self-employed?
Offer a terse response. 57.18. In the year 2009, what is the difference between the Employment (as % of total employment) in Agriculture and Employment (as % of total employment) in Industry?
Provide a short and direct response. -19.55. In the year 2009, what is the difference between the Employment (as % of total employment) in Agriculture and Employment (as % of total employment) in Services?
Your response must be concise. -67.89. In the year 2009, what is the difference between the Employment (as % of total employment) in Agriculture and Employment (as % of total employment) in Self-employed?
Offer a very short reply. -9.38. In the year 2009, what is the difference between the Employment (as % of total employment) in Industry and Employment (as % of total employment) in Services?
Give a very brief answer. -48.34. In the year 2009, what is the difference between the Employment (as % of total employment) of Industry and Employment (as % of total employment) of Self-employed?
Offer a very short reply. 10.17. In the year 2009, what is the difference between the Employment (as % of total employment) in Services and Employment (as % of total employment) in Self-employed?
Provide a short and direct response. 58.51. In the year 2010, what is the difference between the Employment (as % of total employment) of Agriculture and Employment (as % of total employment) of Industry?
Your response must be concise. -19.05. In the year 2010, what is the difference between the Employment (as % of total employment) of Agriculture and Employment (as % of total employment) of Services?
Offer a terse response. -68.39. In the year 2010, what is the difference between the Employment (as % of total employment) in Agriculture and Employment (as % of total employment) in Self-employed?
Provide a succinct answer. -9.44. In the year 2010, what is the difference between the Employment (as % of total employment) of Industry and Employment (as % of total employment) of Services?
Make the answer very short. -49.33. In the year 2010, what is the difference between the Employment (as % of total employment) of Industry and Employment (as % of total employment) of Self-employed?
Keep it short and to the point. 9.61. In the year 2010, what is the difference between the Employment (as % of total employment) of Services and Employment (as % of total employment) of Self-employed?
Offer a very short reply. 58.94. What is the ratio of the Employment (as % of total employment) in Agriculture in 2003 to that in 2004?
Make the answer very short. 1.05. What is the ratio of the Employment (as % of total employment) of Self-employed in 2003 to that in 2004?
Your answer should be compact. 1.01. What is the ratio of the Employment (as % of total employment) of Agriculture in 2003 to that in 2005?
Make the answer very short. 1.07. What is the ratio of the Employment (as % of total employment) in Industry in 2003 to that in 2005?
Ensure brevity in your answer.  1.01. What is the ratio of the Employment (as % of total employment) of Services in 2003 to that in 2005?
Offer a terse response. 0.99. What is the ratio of the Employment (as % of total employment) in Self-employed in 2003 to that in 2005?
Offer a very short reply. 1.02. What is the ratio of the Employment (as % of total employment) in Agriculture in 2003 to that in 2006?
Give a very brief answer. 1.11. What is the ratio of the Employment (as % of total employment) of Industry in 2003 to that in 2006?
Offer a terse response. 1.02. What is the ratio of the Employment (as % of total employment) in Self-employed in 2003 to that in 2006?
Keep it short and to the point. 1.04. What is the ratio of the Employment (as % of total employment) in Agriculture in 2003 to that in 2007?
Offer a very short reply. 1.17. What is the ratio of the Employment (as % of total employment) of Industry in 2003 to that in 2007?
Make the answer very short. 1.02. What is the ratio of the Employment (as % of total employment) of Services in 2003 to that in 2007?
Offer a terse response. 0.98. What is the ratio of the Employment (as % of total employment) of Self-employed in 2003 to that in 2007?
Your answer should be very brief. 1.06. What is the ratio of the Employment (as % of total employment) of Agriculture in 2003 to that in 2008?
Provide a short and direct response. 1.22. What is the ratio of the Employment (as % of total employment) in Industry in 2003 to that in 2008?
Make the answer very short. 1.04. What is the ratio of the Employment (as % of total employment) in Services in 2003 to that in 2008?
Provide a short and direct response. 0.98. What is the ratio of the Employment (as % of total employment) in Self-employed in 2003 to that in 2008?
Make the answer very short. 1.08. What is the ratio of the Employment (as % of total employment) in Agriculture in 2003 to that in 2009?
Your answer should be very brief. 1.23. What is the ratio of the Employment (as % of total employment) of Industry in 2003 to that in 2009?
Provide a short and direct response. 1.1. What is the ratio of the Employment (as % of total employment) in Services in 2003 to that in 2009?
Offer a terse response. 0.96. What is the ratio of the Employment (as % of total employment) of Self-employed in 2003 to that in 2009?
Provide a succinct answer. 1.07. What is the ratio of the Employment (as % of total employment) in Agriculture in 2003 to that in 2010?
Your response must be concise. 1.23. What is the ratio of the Employment (as % of total employment) in Industry in 2003 to that in 2010?
Offer a terse response. 1.12. What is the ratio of the Employment (as % of total employment) of Services in 2003 to that in 2010?
Ensure brevity in your answer.  0.95. What is the ratio of the Employment (as % of total employment) in Self-employed in 2003 to that in 2010?
Provide a short and direct response. 1.07. What is the ratio of the Employment (as % of total employment) in Agriculture in 2004 to that in 2005?
Keep it short and to the point. 1.01. What is the ratio of the Employment (as % of total employment) in Industry in 2004 to that in 2005?
Your response must be concise. 1.01. What is the ratio of the Employment (as % of total employment) in Services in 2004 to that in 2005?
Your answer should be very brief. 1. What is the ratio of the Employment (as % of total employment) in Self-employed in 2004 to that in 2005?
Offer a very short reply. 1.01. What is the ratio of the Employment (as % of total employment) in Agriculture in 2004 to that in 2006?
Your answer should be very brief. 1.05. What is the ratio of the Employment (as % of total employment) of Industry in 2004 to that in 2006?
Provide a succinct answer. 1.01. What is the ratio of the Employment (as % of total employment) of Self-employed in 2004 to that in 2006?
Provide a succinct answer. 1.03. What is the ratio of the Employment (as % of total employment) in Agriculture in 2004 to that in 2007?
Make the answer very short. 1.11. What is the ratio of the Employment (as % of total employment) of Industry in 2004 to that in 2007?
Provide a short and direct response. 1.02. What is the ratio of the Employment (as % of total employment) of Services in 2004 to that in 2007?
Offer a very short reply. 0.99. What is the ratio of the Employment (as % of total employment) in Self-employed in 2004 to that in 2007?
Make the answer very short. 1.05. What is the ratio of the Employment (as % of total employment) of Agriculture in 2004 to that in 2008?
Provide a succinct answer. 1.16. What is the ratio of the Employment (as % of total employment) in Industry in 2004 to that in 2008?
Offer a terse response. 1.03. What is the ratio of the Employment (as % of total employment) in Services in 2004 to that in 2008?
Offer a terse response. 0.98. What is the ratio of the Employment (as % of total employment) in Self-employed in 2004 to that in 2008?
Make the answer very short. 1.07. What is the ratio of the Employment (as % of total employment) in Agriculture in 2004 to that in 2009?
Your answer should be very brief. 1.17. What is the ratio of the Employment (as % of total employment) in Industry in 2004 to that in 2009?
Offer a terse response. 1.1. What is the ratio of the Employment (as % of total employment) in Services in 2004 to that in 2009?
Your answer should be very brief. 0.96. What is the ratio of the Employment (as % of total employment) in Self-employed in 2004 to that in 2009?
Provide a short and direct response. 1.06. What is the ratio of the Employment (as % of total employment) of Agriculture in 2004 to that in 2010?
Provide a succinct answer. 1.17. What is the ratio of the Employment (as % of total employment) in Industry in 2004 to that in 2010?
Provide a succinct answer. 1.12. What is the ratio of the Employment (as % of total employment) of Services in 2004 to that in 2010?
Make the answer very short. 0.95. What is the ratio of the Employment (as % of total employment) in Self-employed in 2004 to that in 2010?
Give a very brief answer. 1.06. What is the ratio of the Employment (as % of total employment) of Agriculture in 2005 to that in 2006?
Provide a short and direct response. 1.04. What is the ratio of the Employment (as % of total employment) of Industry in 2005 to that in 2006?
Offer a terse response. 1.01. What is the ratio of the Employment (as % of total employment) of Self-employed in 2005 to that in 2006?
Your answer should be very brief. 1.02. What is the ratio of the Employment (as % of total employment) of Agriculture in 2005 to that in 2007?
Give a very brief answer. 1.09. What is the ratio of the Employment (as % of total employment) in Industry in 2005 to that in 2007?
Make the answer very short. 1.01. What is the ratio of the Employment (as % of total employment) in Services in 2005 to that in 2007?
Your answer should be compact. 0.99. What is the ratio of the Employment (as % of total employment) in Self-employed in 2005 to that in 2007?
Keep it short and to the point. 1.04. What is the ratio of the Employment (as % of total employment) of Agriculture in 2005 to that in 2008?
Make the answer very short. 1.15. What is the ratio of the Employment (as % of total employment) of Industry in 2005 to that in 2008?
Offer a terse response. 1.02. What is the ratio of the Employment (as % of total employment) of Services in 2005 to that in 2008?
Provide a succinct answer. 0.98. What is the ratio of the Employment (as % of total employment) in Self-employed in 2005 to that in 2008?
Keep it short and to the point. 1.06. What is the ratio of the Employment (as % of total employment) in Agriculture in 2005 to that in 2009?
Offer a terse response. 1.15. What is the ratio of the Employment (as % of total employment) of Industry in 2005 to that in 2009?
Provide a succinct answer. 1.09. What is the ratio of the Employment (as % of total employment) in Services in 2005 to that in 2009?
Your response must be concise. 0.96. What is the ratio of the Employment (as % of total employment) of Self-employed in 2005 to that in 2009?
Make the answer very short. 1.05. What is the ratio of the Employment (as % of total employment) of Agriculture in 2005 to that in 2010?
Your answer should be compact. 1.15. What is the ratio of the Employment (as % of total employment) in Industry in 2005 to that in 2010?
Ensure brevity in your answer.  1.11. What is the ratio of the Employment (as % of total employment) in Services in 2005 to that in 2010?
Offer a very short reply. 0.96. What is the ratio of the Employment (as % of total employment) in Self-employed in 2005 to that in 2010?
Your answer should be compact. 1.05. What is the ratio of the Employment (as % of total employment) of Agriculture in 2006 to that in 2007?
Keep it short and to the point. 1.05. What is the ratio of the Employment (as % of total employment) of Industry in 2006 to that in 2007?
Make the answer very short. 1. What is the ratio of the Employment (as % of total employment) of Services in 2006 to that in 2007?
Give a very brief answer. 1. What is the ratio of the Employment (as % of total employment) in Self-employed in 2006 to that in 2007?
Ensure brevity in your answer.  1.02. What is the ratio of the Employment (as % of total employment) in Agriculture in 2006 to that in 2008?
Provide a short and direct response. 1.1. What is the ratio of the Employment (as % of total employment) in Industry in 2006 to that in 2008?
Offer a terse response. 1.02. What is the ratio of the Employment (as % of total employment) in Services in 2006 to that in 2008?
Your answer should be compact. 0.99. What is the ratio of the Employment (as % of total employment) in Self-employed in 2006 to that in 2008?
Make the answer very short. 1.04. What is the ratio of the Employment (as % of total employment) of Agriculture in 2006 to that in 2009?
Your response must be concise. 1.11. What is the ratio of the Employment (as % of total employment) of Industry in 2006 to that in 2009?
Offer a very short reply. 1.08. What is the ratio of the Employment (as % of total employment) of Services in 2006 to that in 2009?
Give a very brief answer. 0.97. What is the ratio of the Employment (as % of total employment) in Self-employed in 2006 to that in 2009?
Offer a very short reply. 1.03. What is the ratio of the Employment (as % of total employment) in Agriculture in 2006 to that in 2010?
Your answer should be very brief. 1.11. What is the ratio of the Employment (as % of total employment) in Industry in 2006 to that in 2010?
Give a very brief answer. 1.1. What is the ratio of the Employment (as % of total employment) of Services in 2006 to that in 2010?
Offer a very short reply. 0.96. What is the ratio of the Employment (as % of total employment) in Agriculture in 2007 to that in 2008?
Your response must be concise. 1.05. What is the ratio of the Employment (as % of total employment) in Industry in 2007 to that in 2008?
Your response must be concise. 1.02. What is the ratio of the Employment (as % of total employment) of Services in 2007 to that in 2008?
Offer a very short reply. 0.99. What is the ratio of the Employment (as % of total employment) in Self-employed in 2007 to that in 2008?
Your response must be concise. 1.02. What is the ratio of the Employment (as % of total employment) of Agriculture in 2007 to that in 2009?
Offer a very short reply. 1.05. What is the ratio of the Employment (as % of total employment) in Industry in 2007 to that in 2009?
Your response must be concise. 1.08. What is the ratio of the Employment (as % of total employment) of Services in 2007 to that in 2009?
Offer a terse response. 0.97. What is the ratio of the Employment (as % of total employment) of Agriculture in 2007 to that in 2010?
Your response must be concise. 1.06. What is the ratio of the Employment (as % of total employment) in Industry in 2007 to that in 2010?
Ensure brevity in your answer.  1.1. What is the ratio of the Employment (as % of total employment) of Services in 2007 to that in 2010?
Offer a terse response. 0.97. What is the ratio of the Employment (as % of total employment) of Self-employed in 2007 to that in 2010?
Keep it short and to the point. 1.01. What is the ratio of the Employment (as % of total employment) of Industry in 2008 to that in 2009?
Your response must be concise. 1.06. What is the ratio of the Employment (as % of total employment) of Services in 2008 to that in 2009?
Give a very brief answer. 0.98. What is the ratio of the Employment (as % of total employment) in Agriculture in 2008 to that in 2010?
Provide a succinct answer. 1.01. What is the ratio of the Employment (as % of total employment) of Industry in 2008 to that in 2010?
Offer a very short reply. 1.08. What is the ratio of the Employment (as % of total employment) of Services in 2008 to that in 2010?
Your answer should be compact. 0.97. What is the ratio of the Employment (as % of total employment) in Self-employed in 2008 to that in 2010?
Your answer should be very brief. 0.99. What is the ratio of the Employment (as % of total employment) in Agriculture in 2009 to that in 2010?
Offer a very short reply. 1. What is the ratio of the Employment (as % of total employment) in Industry in 2009 to that in 2010?
Offer a terse response. 1.02. What is the ratio of the Employment (as % of total employment) of Services in 2009 to that in 2010?
Keep it short and to the point. 0.99. What is the difference between the highest and the second highest Employment (as % of total employment) of Agriculture?
Provide a succinct answer. 0.25. What is the difference between the highest and the second highest Employment (as % of total employment) in Industry?
Offer a terse response. 0.09. What is the difference between the highest and the second highest Employment (as % of total employment) of Services?
Offer a terse response. 0.48. What is the difference between the highest and the second highest Employment (as % of total employment) of Self-employed?
Offer a very short reply. 0.08. What is the difference between the highest and the lowest Employment (as % of total employment) of Agriculture?
Your answer should be very brief. 0.94. What is the difference between the highest and the lowest Employment (as % of total employment) in Industry?
Ensure brevity in your answer.  2.86. What is the difference between the highest and the lowest Employment (as % of total employment) of Services?
Your answer should be compact. 3.59. What is the difference between the highest and the lowest Employment (as % of total employment) in Self-employed?
Ensure brevity in your answer.  1.03. 